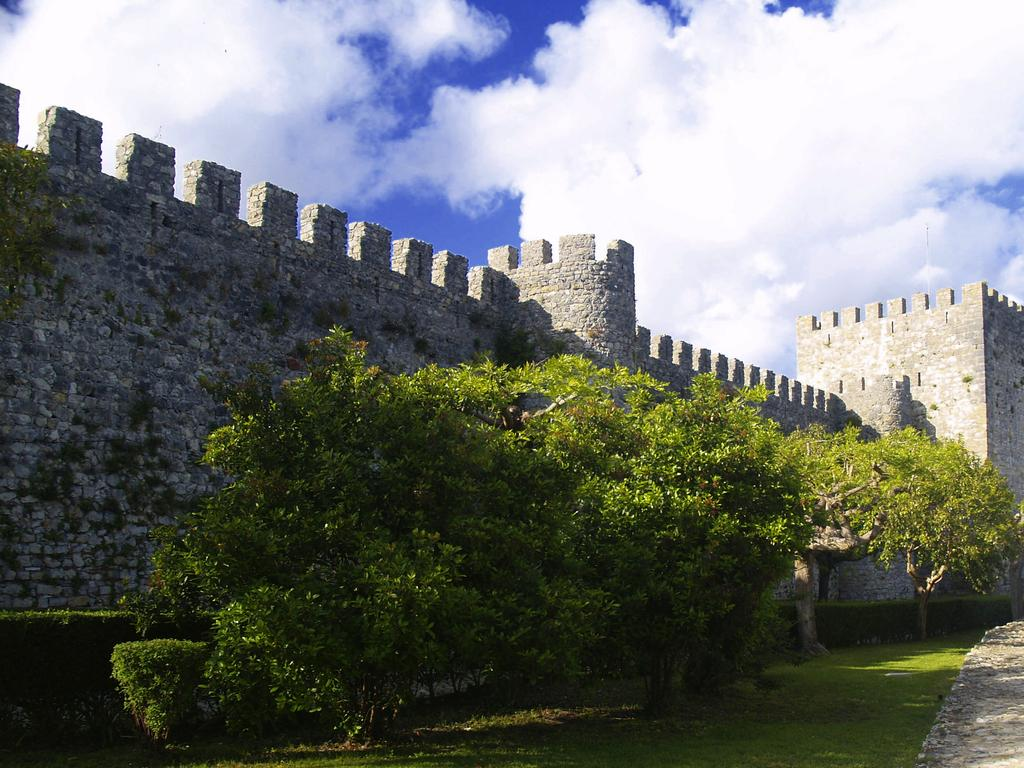What type of vegetation is in the front of the image? There are trees in the front of the image. What type of ground cover is at the bottom of the image? There is grass at the bottom of the image. What type of structure can be seen in the background of the image? There is a fort in the background of the image. What is visible at the top of the image? The sky is visible at the top of the image. What can be seen in the sky? Clouds are present in the sky. Where is the oven located in the image? There is no oven present in the image. Can you describe the man standing near the fort in the image? There is no man present in the image. 